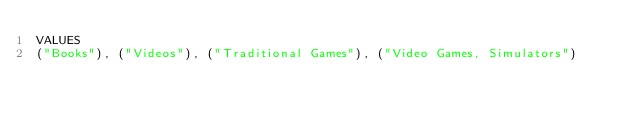Convert code to text. <code><loc_0><loc_0><loc_500><loc_500><_SQL_>VALUES
("Books"), ("Videos"), ("Traditional Games"), ("Video Games, Simulators")</code> 